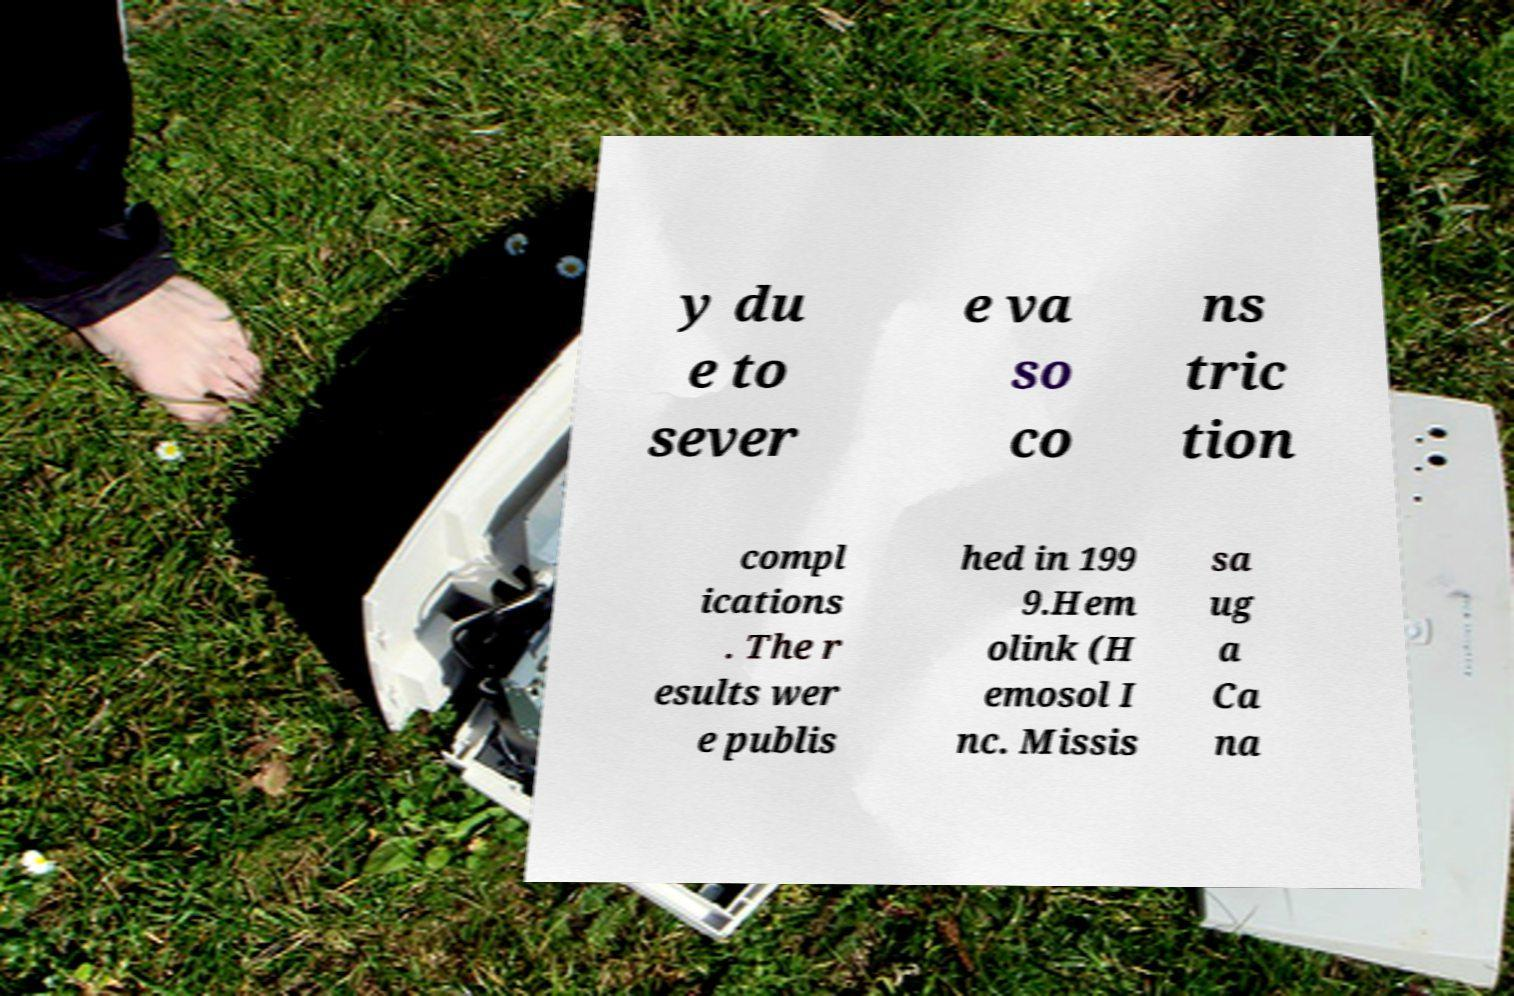For documentation purposes, I need the text within this image transcribed. Could you provide that? y du e to sever e va so co ns tric tion compl ications . The r esults wer e publis hed in 199 9.Hem olink (H emosol I nc. Missis sa ug a Ca na 